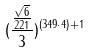Convert formula to latex. <formula><loc_0><loc_0><loc_500><loc_500>( \frac { \frac { \sqrt { 6 } } { 2 2 1 } } { 3 } ) ^ { ( 3 4 9 \cdot 4 ) + 1 }</formula> 